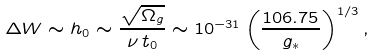Convert formula to latex. <formula><loc_0><loc_0><loc_500><loc_500>\Delta W \sim h _ { 0 } \sim \frac { \sqrt { \Omega _ { g } } } { \nu \, t _ { 0 } } \sim 1 0 ^ { - 3 1 } \left ( \frac { 1 0 6 . 7 5 } { g _ { * } } \right ) ^ { 1 / 3 } ,</formula> 